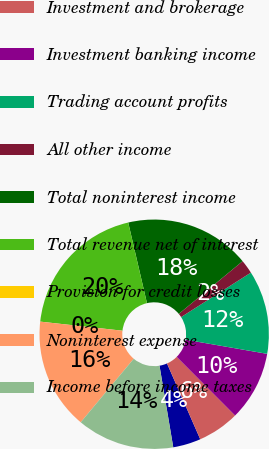<chart> <loc_0><loc_0><loc_500><loc_500><pie_chart><fcel>Service charges<fcel>Investment and brokerage<fcel>Investment banking income<fcel>Trading account profits<fcel>All other income<fcel>Total noninterest income<fcel>Total revenue net of interest<fcel>Provision for credit losses<fcel>Noninterest expense<fcel>Income before income taxes<nl><fcel>3.92%<fcel>5.88%<fcel>9.8%<fcel>11.76%<fcel>1.96%<fcel>17.64%<fcel>19.6%<fcel>0.0%<fcel>15.68%<fcel>13.72%<nl></chart> 